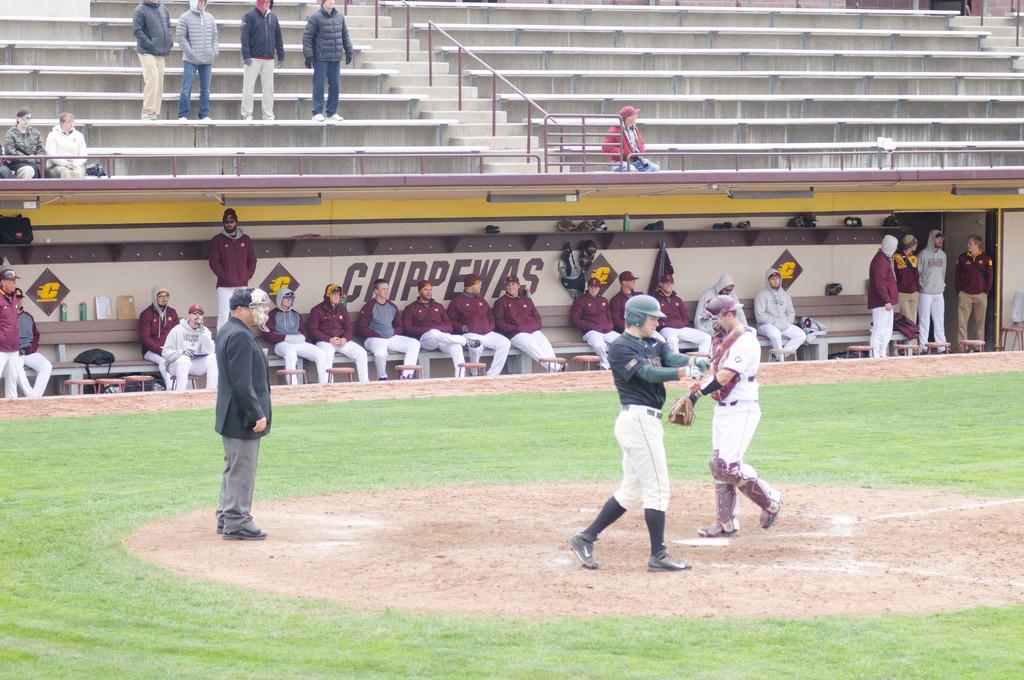What does the dugout say?
Give a very brief answer. Chippewas. What letter is on the diamond shaped signs?
Provide a succinct answer. C. 